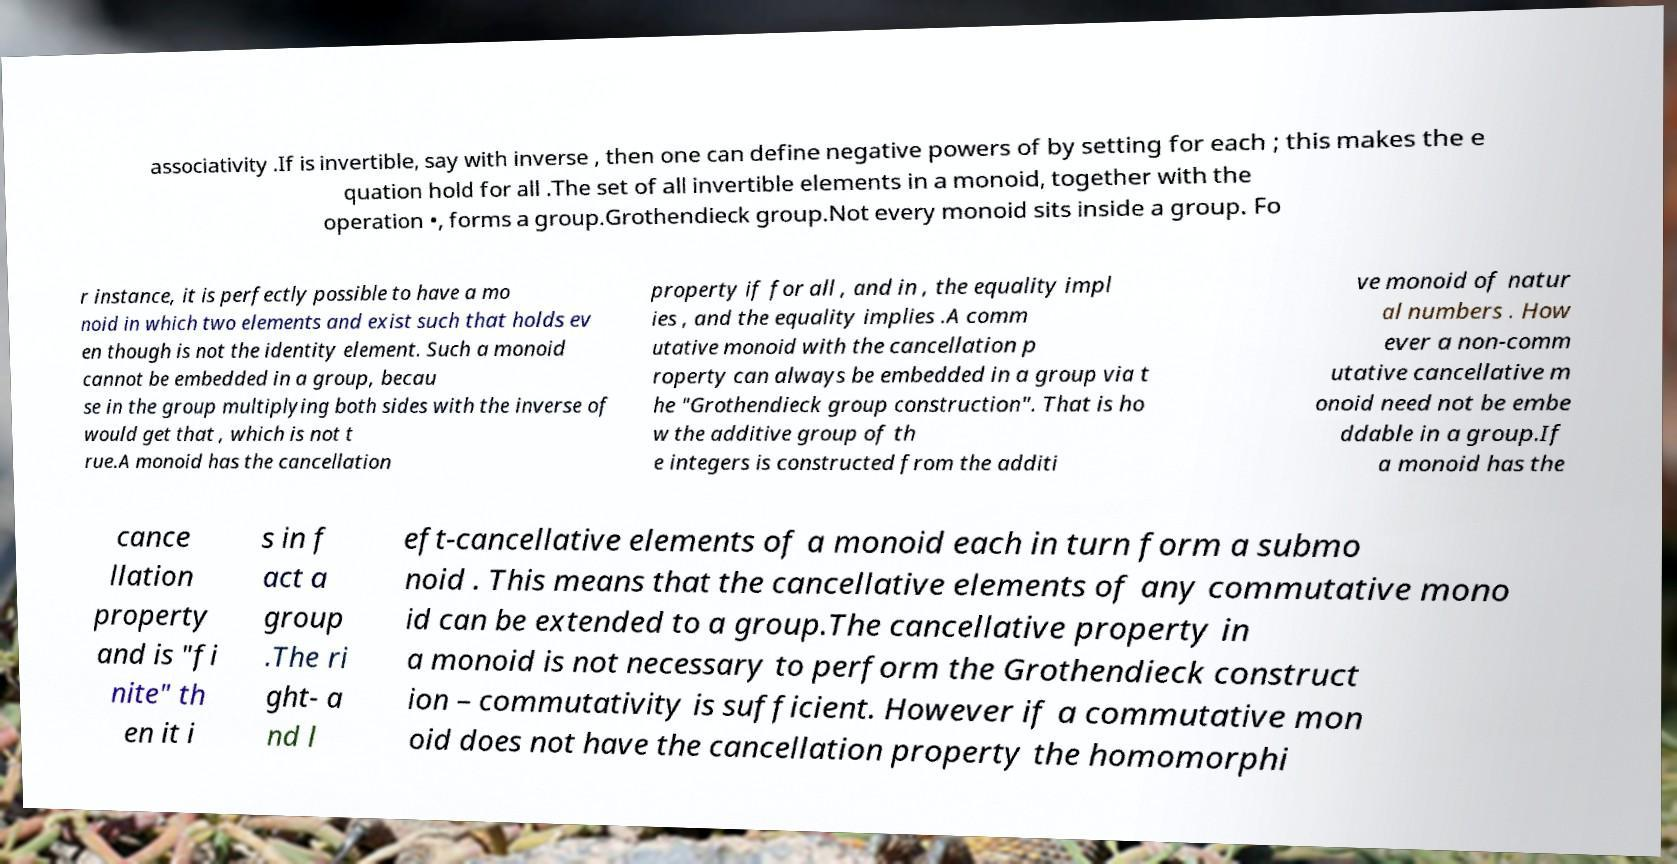Could you assist in decoding the text presented in this image and type it out clearly? associativity .If is invertible, say with inverse , then one can define negative powers of by setting for each ; this makes the e quation hold for all .The set of all invertible elements in a monoid, together with the operation •, forms a group.Grothendieck group.Not every monoid sits inside a group. Fo r instance, it is perfectly possible to have a mo noid in which two elements and exist such that holds ev en though is not the identity element. Such a monoid cannot be embedded in a group, becau se in the group multiplying both sides with the inverse of would get that , which is not t rue.A monoid has the cancellation property if for all , and in , the equality impl ies , and the equality implies .A comm utative monoid with the cancellation p roperty can always be embedded in a group via t he "Grothendieck group construction". That is ho w the additive group of th e integers is constructed from the additi ve monoid of natur al numbers . How ever a non-comm utative cancellative m onoid need not be embe ddable in a group.If a monoid has the cance llation property and is "fi nite" th en it i s in f act a group .The ri ght- a nd l eft-cancellative elements of a monoid each in turn form a submo noid . This means that the cancellative elements of any commutative mono id can be extended to a group.The cancellative property in a monoid is not necessary to perform the Grothendieck construct ion – commutativity is sufficient. However if a commutative mon oid does not have the cancellation property the homomorphi 